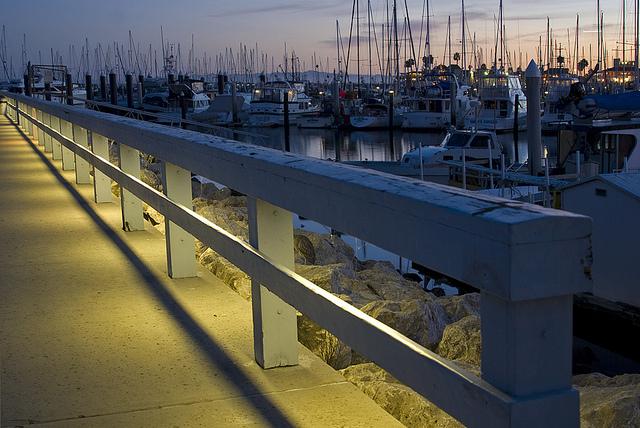Is it day time?
Concise answer only. No. Are these lights bright enough to light your way at night?
Give a very brief answer. Yes. Is the boat moving?
Concise answer only. No. What is parked near the bridge?
Write a very short answer. Boats. 